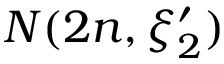Convert formula to latex. <formula><loc_0><loc_0><loc_500><loc_500>N ( 2 n , \xi _ { 2 } ^ { \prime } )</formula> 